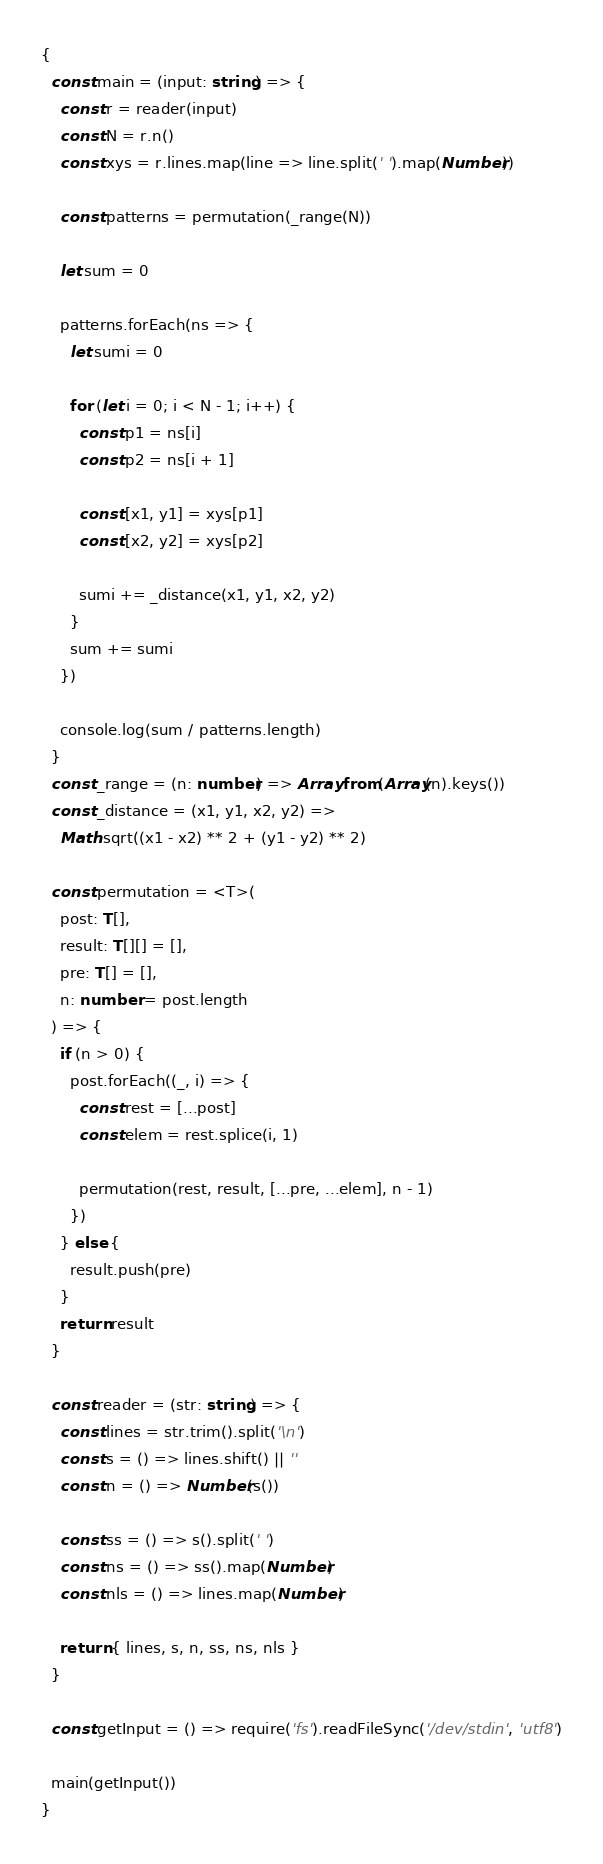Convert code to text. <code><loc_0><loc_0><loc_500><loc_500><_TypeScript_>{
  const main = (input: string) => {
    const r = reader(input)
    const N = r.n()
    const xys = r.lines.map(line => line.split(' ').map(Number))

    const patterns = permutation(_range(N))

    let sum = 0

    patterns.forEach(ns => {
      let sumi = 0

      for (let i = 0; i < N - 1; i++) {
        const p1 = ns[i]
        const p2 = ns[i + 1]

        const [x1, y1] = xys[p1]
        const [x2, y2] = xys[p2]

        sumi += _distance(x1, y1, x2, y2)
      }
      sum += sumi
    })

    console.log(sum / patterns.length)
  }
  const _range = (n: number) => Array.from(Array(n).keys())
  const _distance = (x1, y1, x2, y2) =>
    Math.sqrt((x1 - x2) ** 2 + (y1 - y2) ** 2)

  const permutation = <T>(
    post: T[],
    result: T[][] = [],
    pre: T[] = [],
    n: number = post.length
  ) => {
    if (n > 0) {
      post.forEach((_, i) => {
        const rest = [...post]
        const elem = rest.splice(i, 1)

        permutation(rest, result, [...pre, ...elem], n - 1)
      })
    } else {
      result.push(pre)
    }
    return result
  }

  const reader = (str: string) => {
    const lines = str.trim().split('\n')
    const s = () => lines.shift() || ''
    const n = () => Number(s())

    const ss = () => s().split(' ')
    const ns = () => ss().map(Number)
    const nls = () => lines.map(Number)

    return { lines, s, n, ss, ns, nls }
  }

  const getInput = () => require('fs').readFileSync('/dev/stdin', 'utf8')

  main(getInput())
}
</code> 